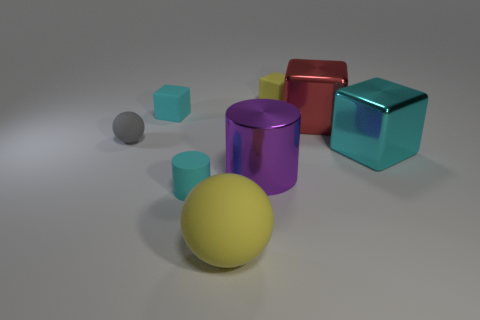Add 1 large yellow objects. How many objects exist? 9 Subtract all cylinders. How many objects are left? 6 Subtract all small balls. Subtract all big yellow balls. How many objects are left? 6 Add 6 big cyan things. How many big cyan things are left? 7 Add 2 small red shiny spheres. How many small red shiny spheres exist? 2 Subtract 0 blue cylinders. How many objects are left? 8 